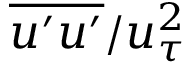<formula> <loc_0><loc_0><loc_500><loc_500>\overline { { u ^ { \prime } u ^ { \prime } } } / { u _ { \tau } ^ { 2 } }</formula> 